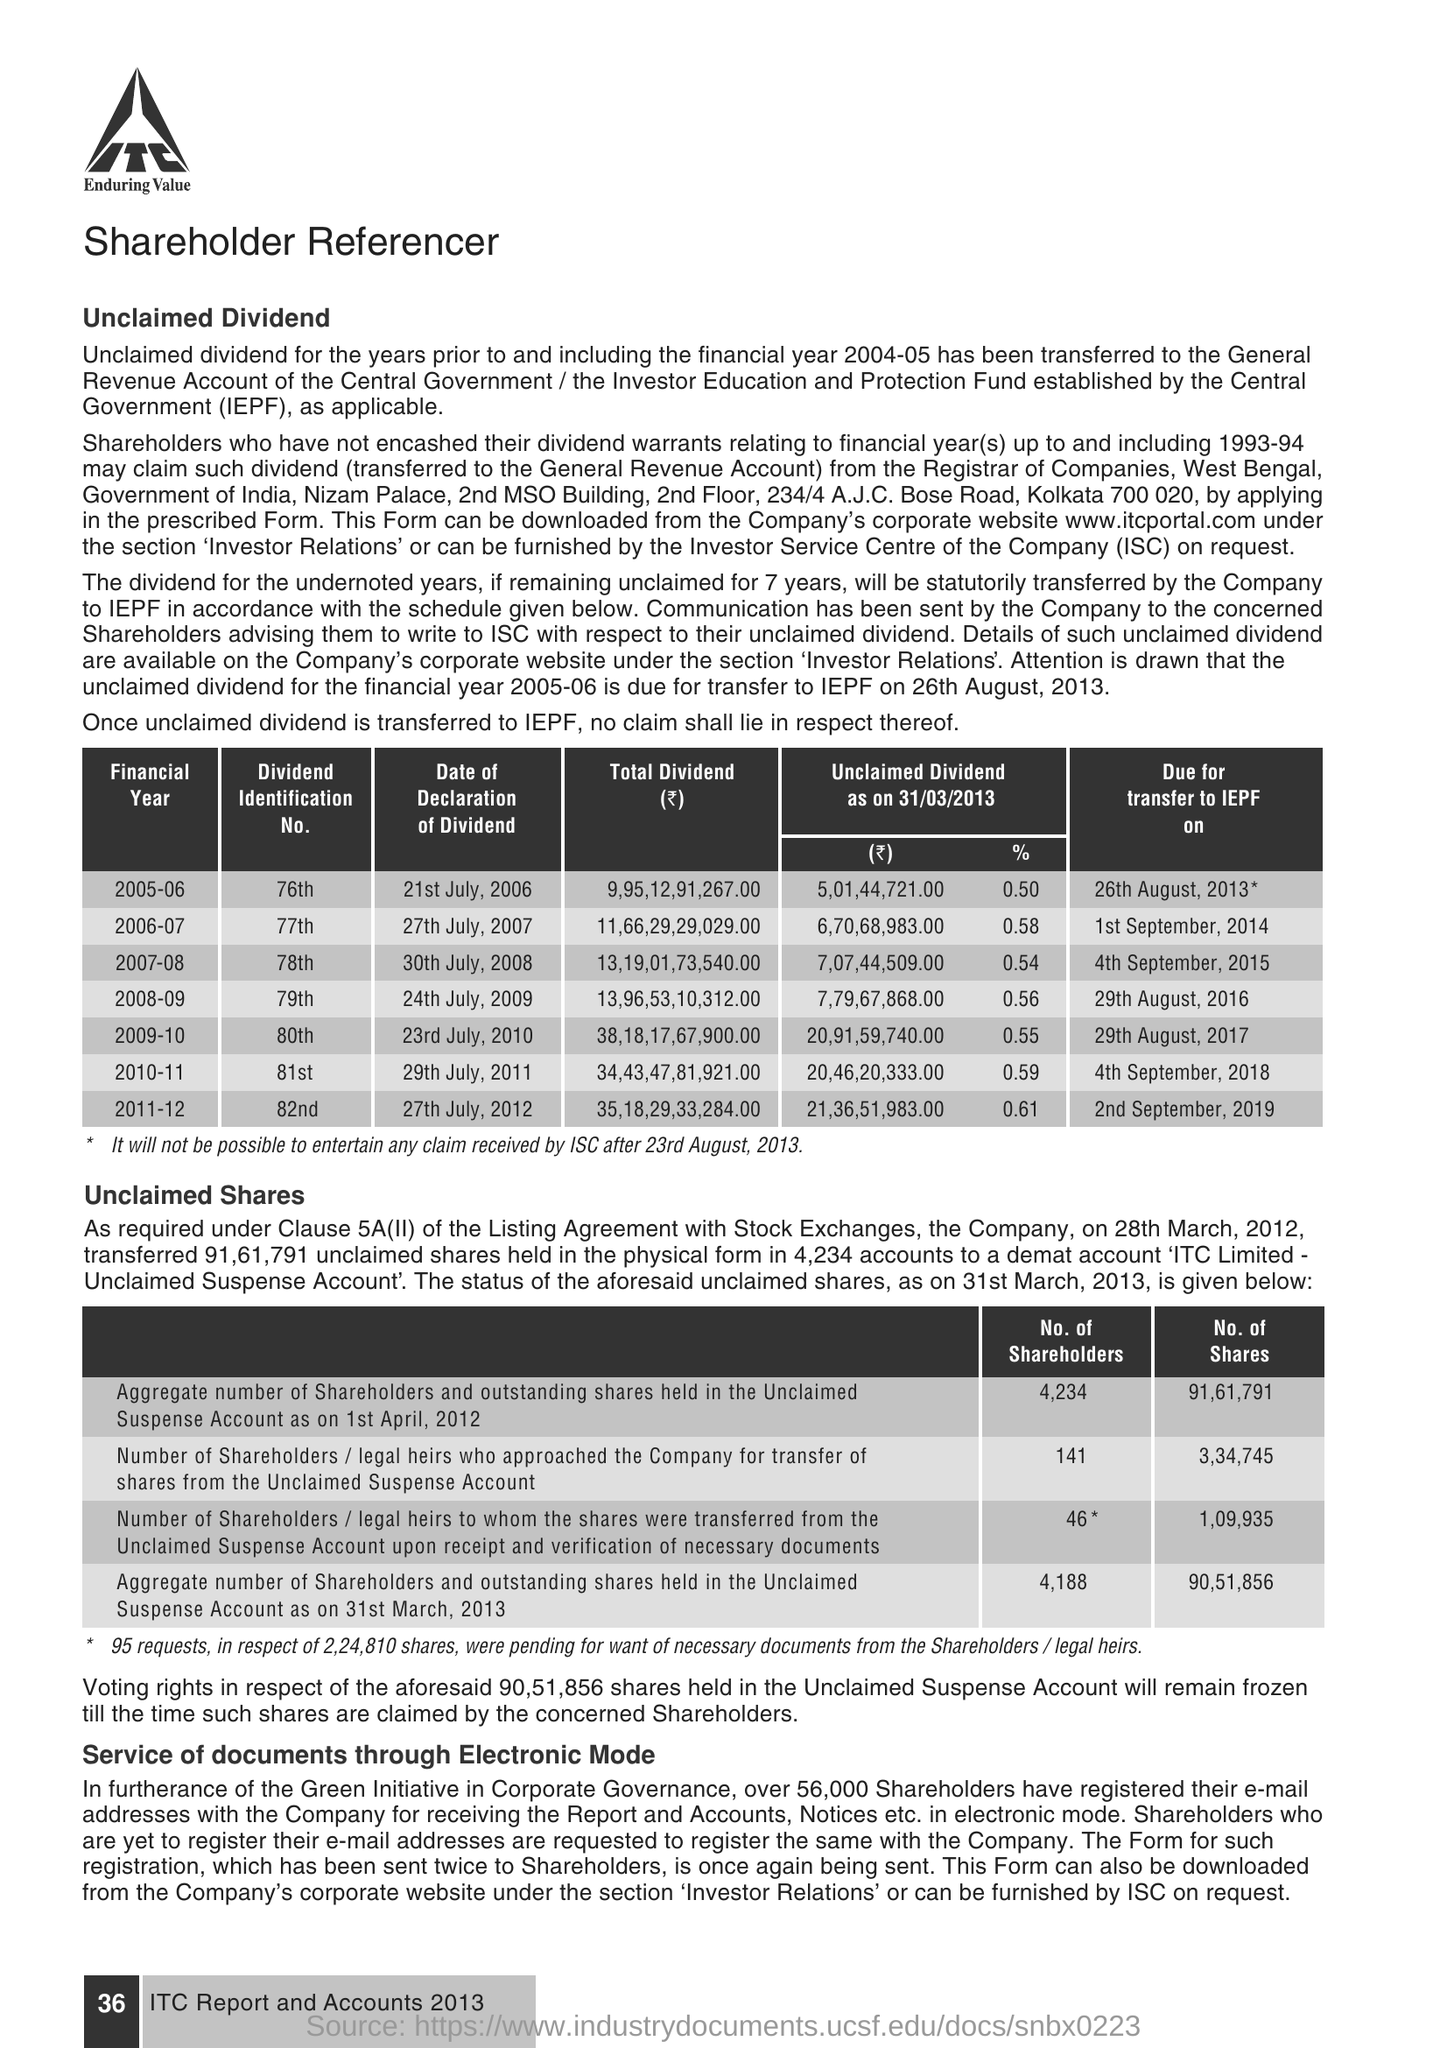What is the date of declaration of dividend for the financial year 2008-09?
Your answer should be very brief. 24th July, 2009. What is the divided identification no for the financial year 2009-10?
Provide a succinct answer. 80th. What does iepf stands for
Provide a short and direct response. Investor Education and Protection Fund. 